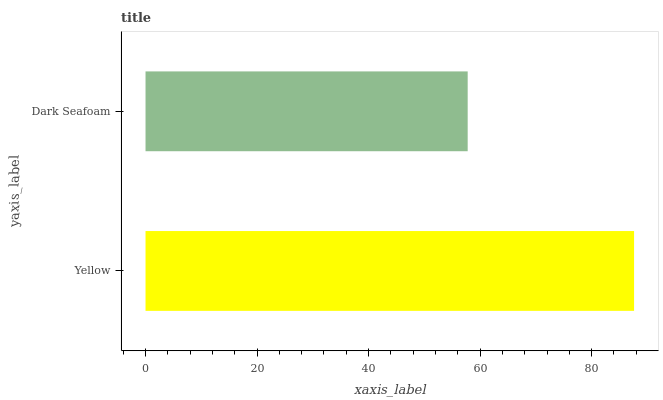Is Dark Seafoam the minimum?
Answer yes or no. Yes. Is Yellow the maximum?
Answer yes or no. Yes. Is Dark Seafoam the maximum?
Answer yes or no. No. Is Yellow greater than Dark Seafoam?
Answer yes or no. Yes. Is Dark Seafoam less than Yellow?
Answer yes or no. Yes. Is Dark Seafoam greater than Yellow?
Answer yes or no. No. Is Yellow less than Dark Seafoam?
Answer yes or no. No. Is Yellow the high median?
Answer yes or no. Yes. Is Dark Seafoam the low median?
Answer yes or no. Yes. Is Dark Seafoam the high median?
Answer yes or no. No. Is Yellow the low median?
Answer yes or no. No. 